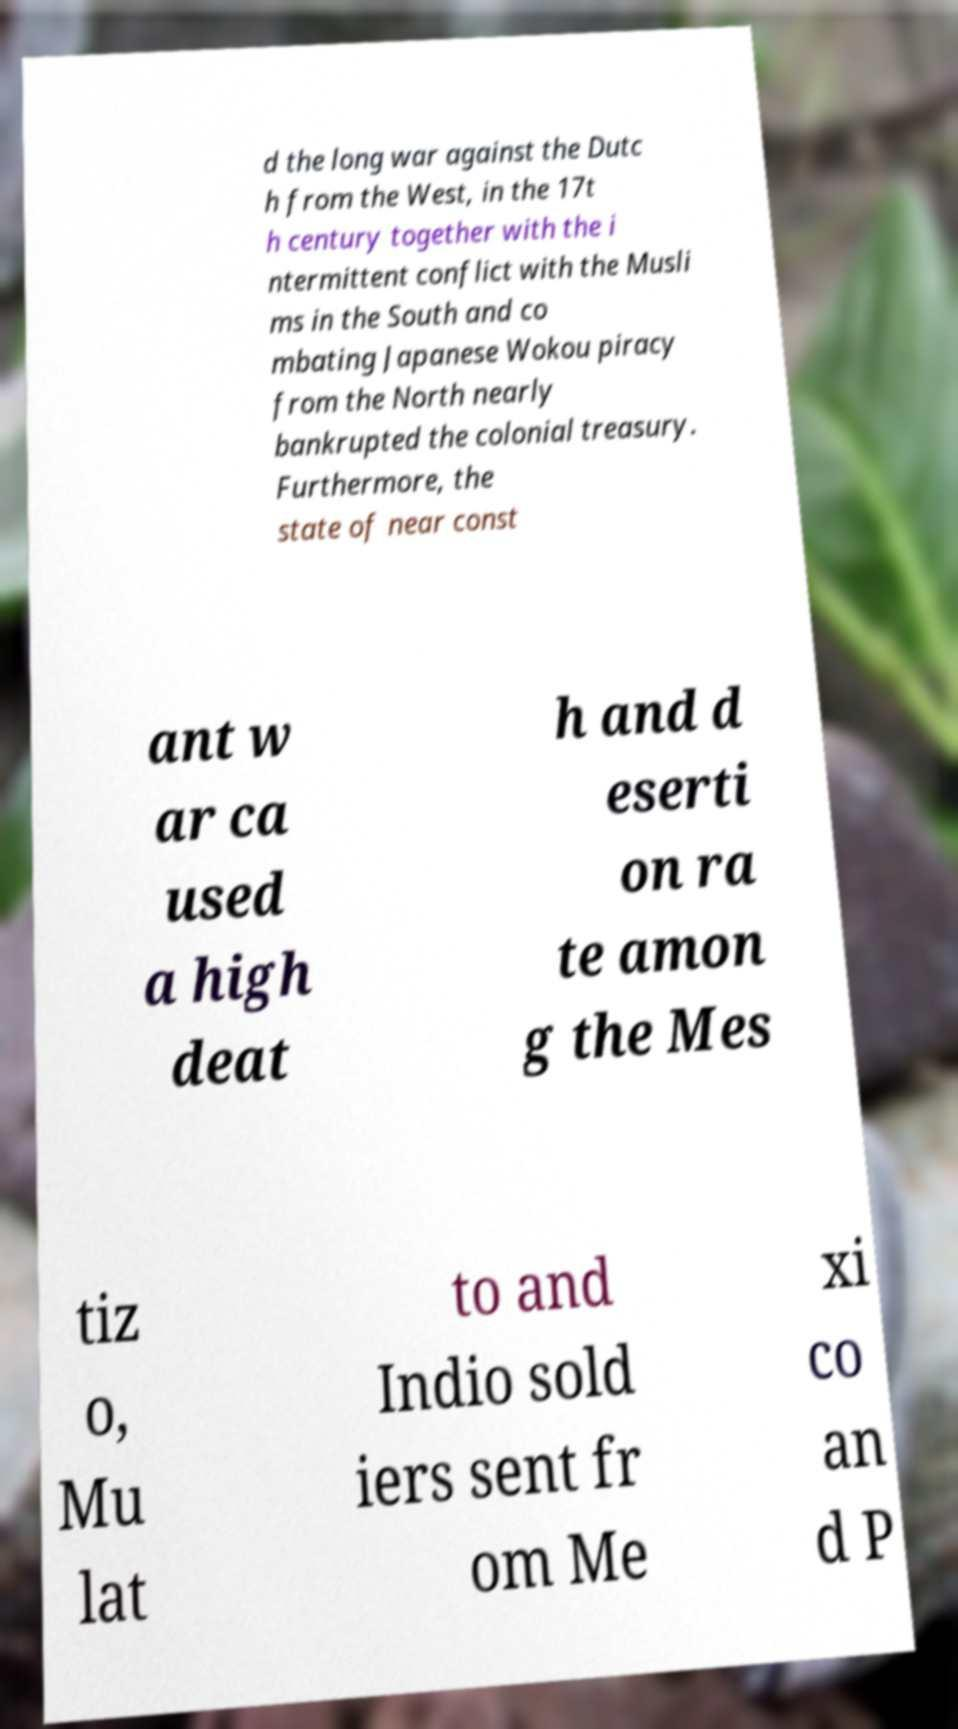Please identify and transcribe the text found in this image. d the long war against the Dutc h from the West, in the 17t h century together with the i ntermittent conflict with the Musli ms in the South and co mbating Japanese Wokou piracy from the North nearly bankrupted the colonial treasury. Furthermore, the state of near const ant w ar ca used a high deat h and d eserti on ra te amon g the Mes tiz o, Mu lat to and Indio sold iers sent fr om Me xi co an d P 